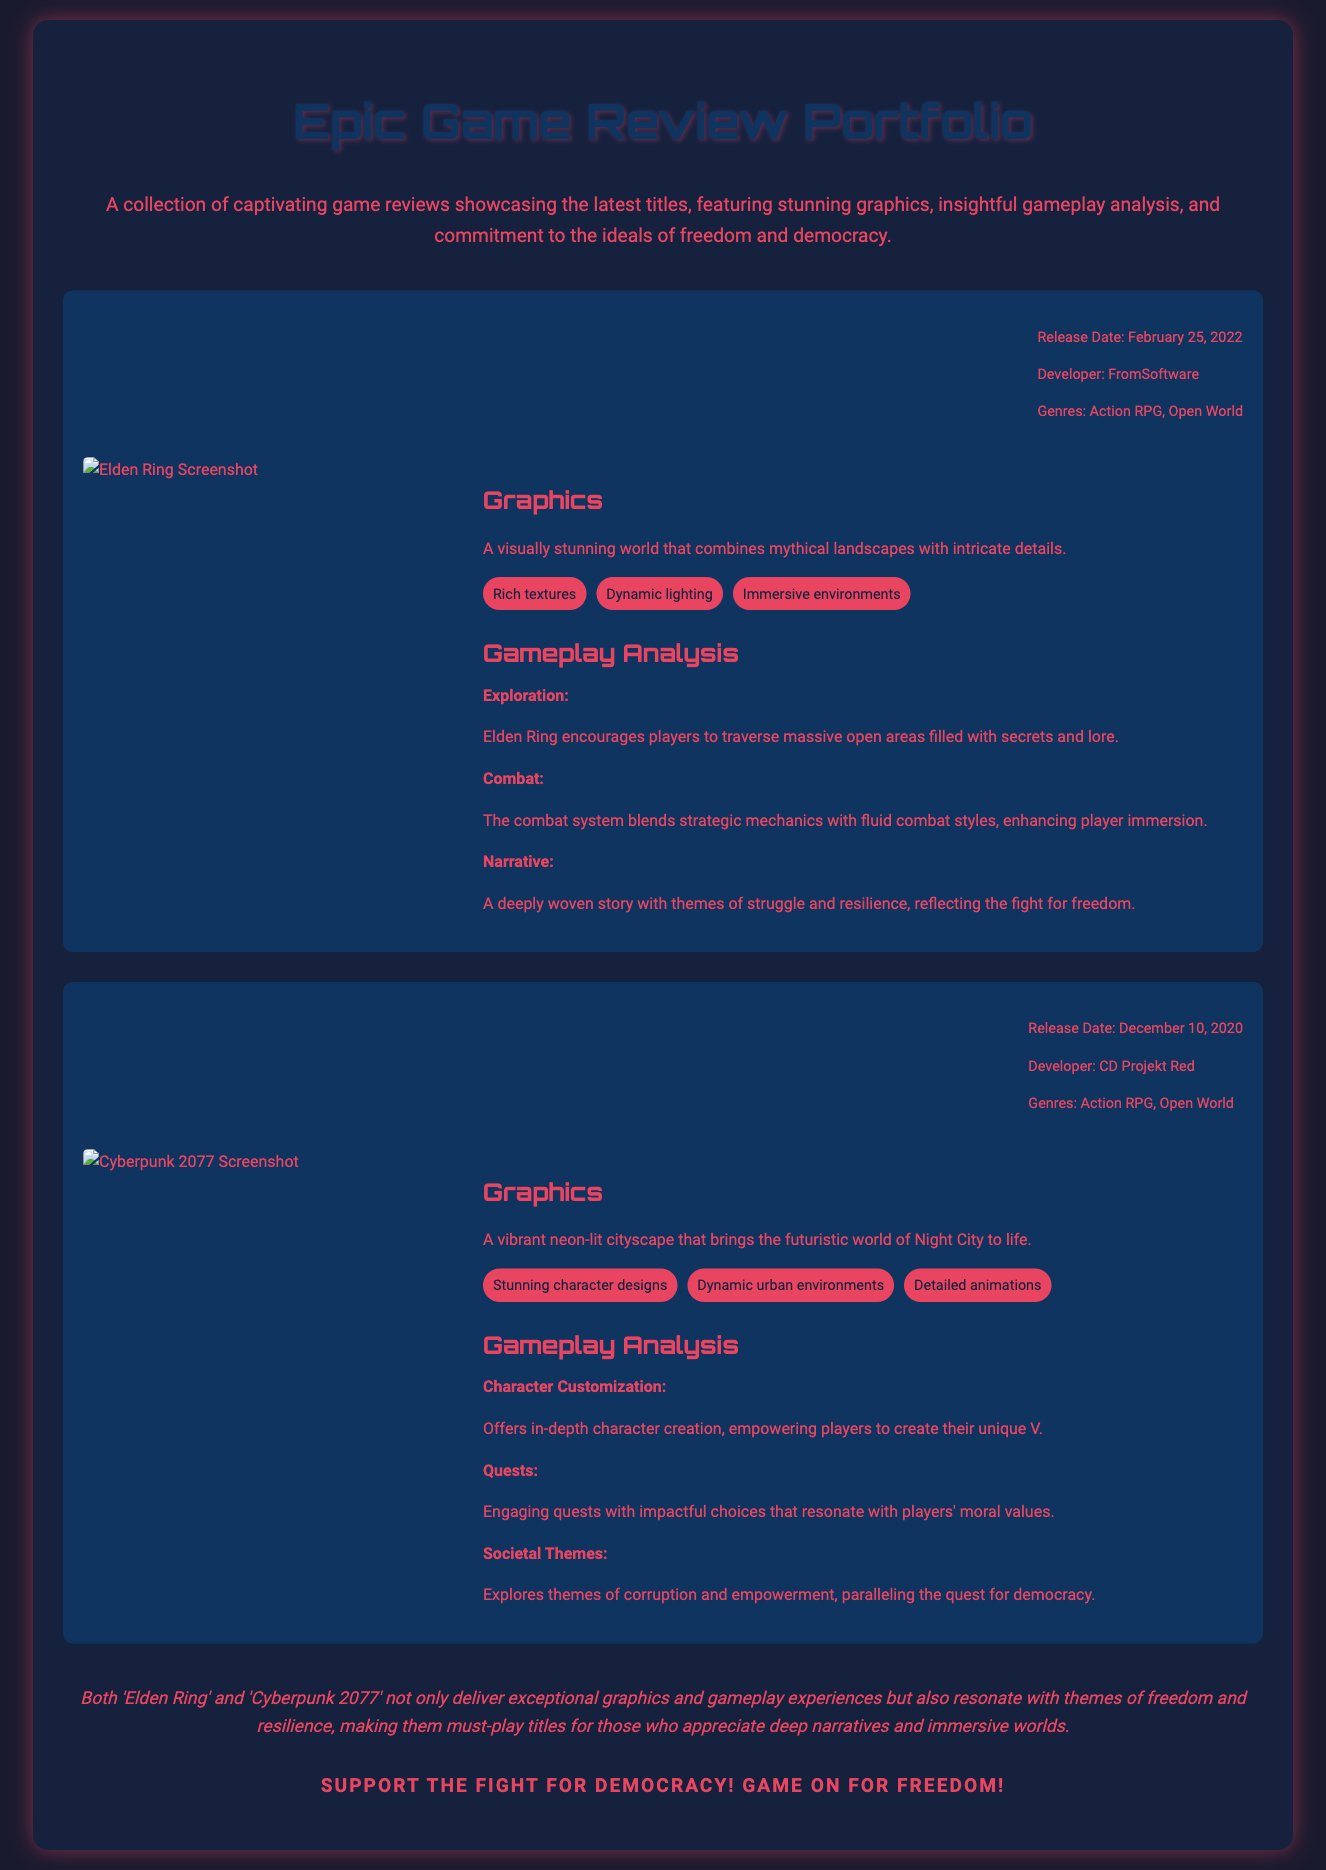What is the release date of Elden Ring? The release date for Elden Ring is specified in the document as February 25, 2022.
Answer: February 25, 2022 Who developed Cyberpunk 2077? The developer of Cyberpunk 2077 is stated as CD Projekt Red in the document.
Answer: CD Projekt Red What genre does Elden Ring belong to? The document indicates that Elden Ring falls under the genres of Action RPG and Open World.
Answer: Action RPG, Open World What key element is mentioned for Elden Ring's graphics? The document lists "Dynamic lighting" as one of the key elements in the graphics section for Elden Ring.
Answer: Dynamic lighting How does the gameplay analysis describe the narrative of Elden Ring? The narrative is described in the document as "A deeply woven story with themes of struggle and resilience."
Answer: A deeply woven story with themes of struggle and resilience How many key elements are listed under Cyberpunk 2077's graphics? The document mentions three key elements: Stunning character designs, Dynamic urban environments, and Detailed animations.
Answer: Three Which theme is explored in Cyberpunk 2077's gameplay analysis? The gameplay analysis explores "themes of corruption and empowerment."
Answer: themes of corruption and empowerment What is the conclusion about both games? The conclusion states that both games "deliver exceptional graphics and gameplay experiences."
Answer: deliver exceptional graphics and gameplay experiences What does the document say about supporting democracy? The document states "Support the fight for democracy! Game on for freedom!"
Answer: Support the fight for democracy! Game on for freedom! 